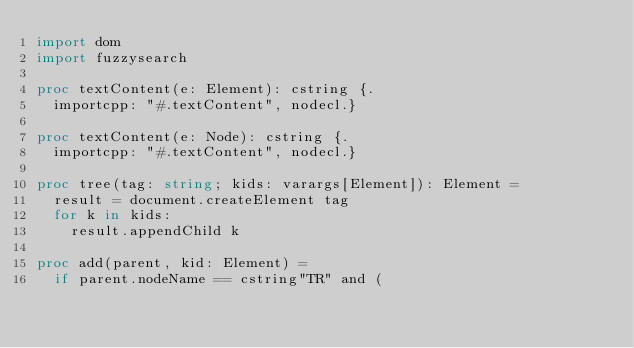<code> <loc_0><loc_0><loc_500><loc_500><_Nim_>import dom
import fuzzysearch

proc textContent(e: Element): cstring {.
  importcpp: "#.textContent", nodecl.}

proc textContent(e: Node): cstring {.
  importcpp: "#.textContent", nodecl.}

proc tree(tag: string; kids: varargs[Element]): Element =
  result = document.createElement tag
  for k in kids:
    result.appendChild k

proc add(parent, kid: Element) =
  if parent.nodeName == cstring"TR" and (</code> 